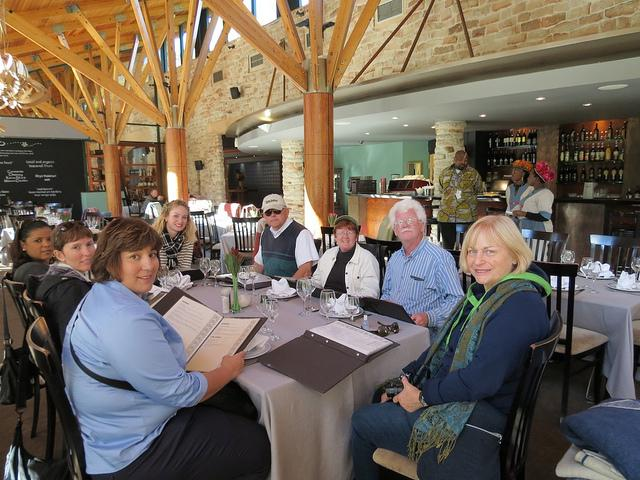What will persons seated here do next? order food 